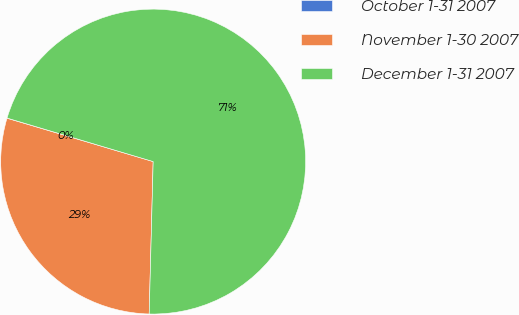Convert chart to OTSL. <chart><loc_0><loc_0><loc_500><loc_500><pie_chart><fcel>October 1-31 2007<fcel>November 1-30 2007<fcel>December 1-31 2007<nl><fcel>0.02%<fcel>29.17%<fcel>70.81%<nl></chart> 